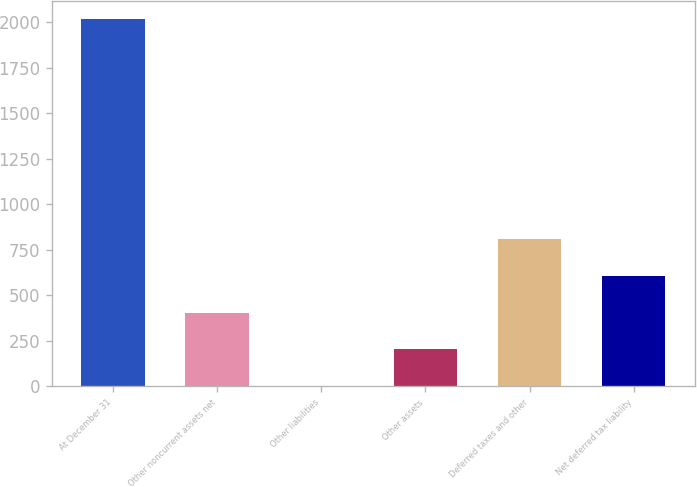Convert chart to OTSL. <chart><loc_0><loc_0><loc_500><loc_500><bar_chart><fcel>At December 31<fcel>Other noncurrent assets net<fcel>Other liabilities<fcel>Other assets<fcel>Deferred taxes and other<fcel>Net deferred tax liability<nl><fcel>2017<fcel>404.92<fcel>1.9<fcel>203.41<fcel>807.94<fcel>606.43<nl></chart> 